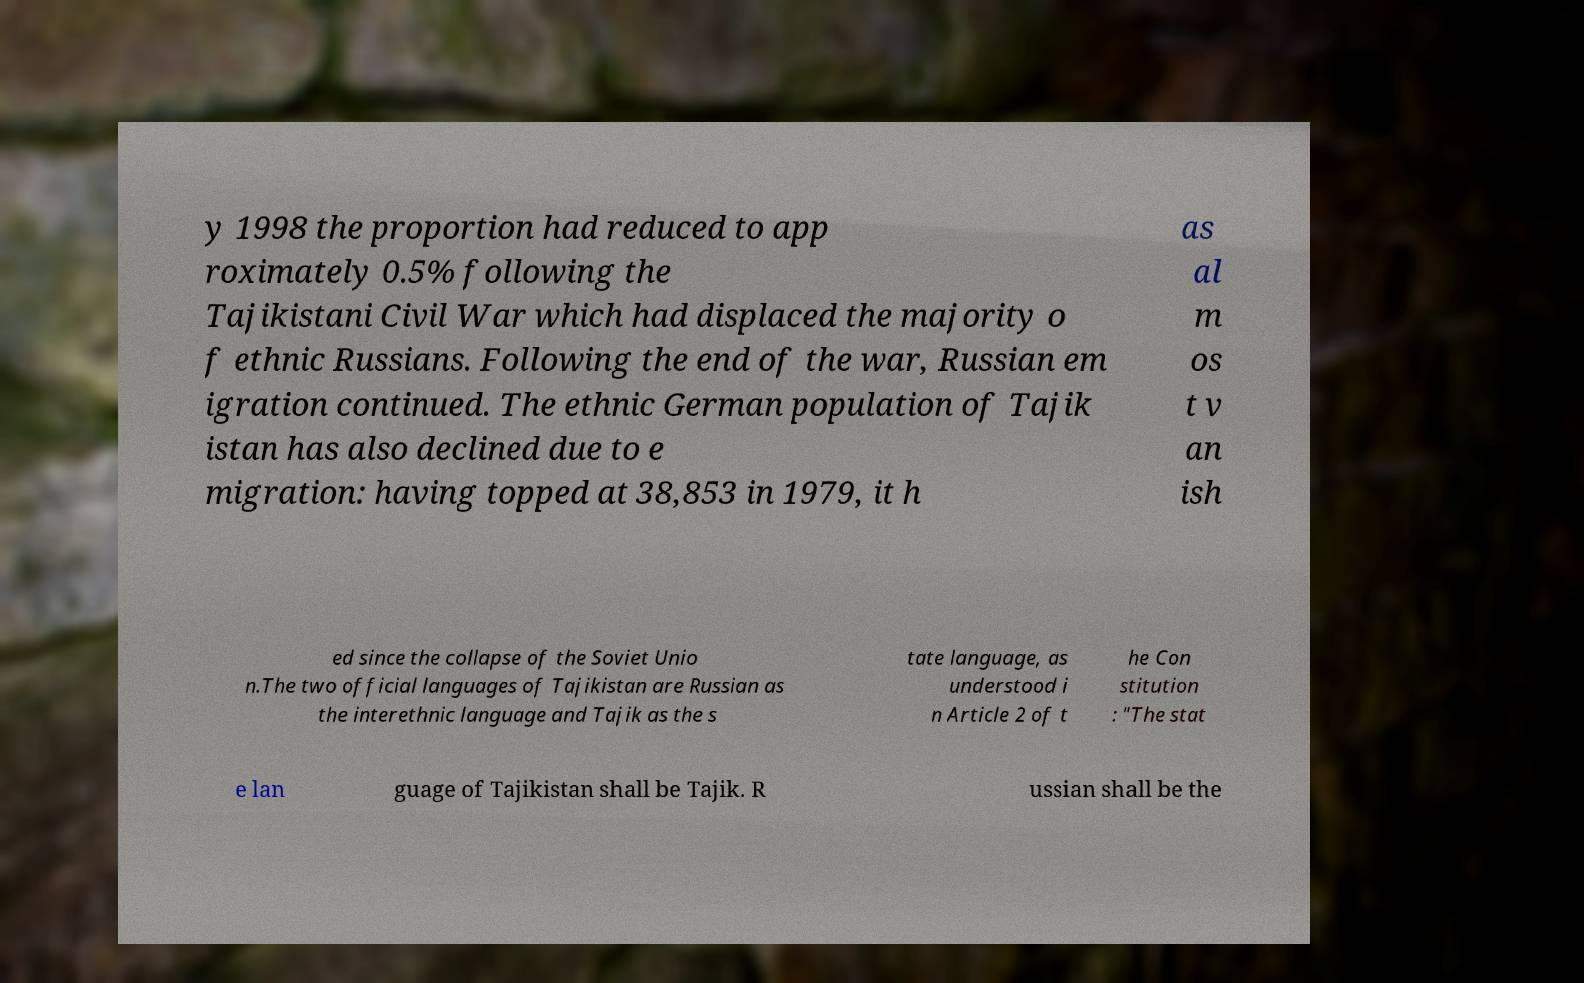Please read and relay the text visible in this image. What does it say? y 1998 the proportion had reduced to app roximately 0.5% following the Tajikistani Civil War which had displaced the majority o f ethnic Russians. Following the end of the war, Russian em igration continued. The ethnic German population of Tajik istan has also declined due to e migration: having topped at 38,853 in 1979, it h as al m os t v an ish ed since the collapse of the Soviet Unio n.The two official languages of Tajikistan are Russian as the interethnic language and Tajik as the s tate language, as understood i n Article 2 of t he Con stitution : "The stat e lan guage of Tajikistan shall be Tajik. R ussian shall be the 